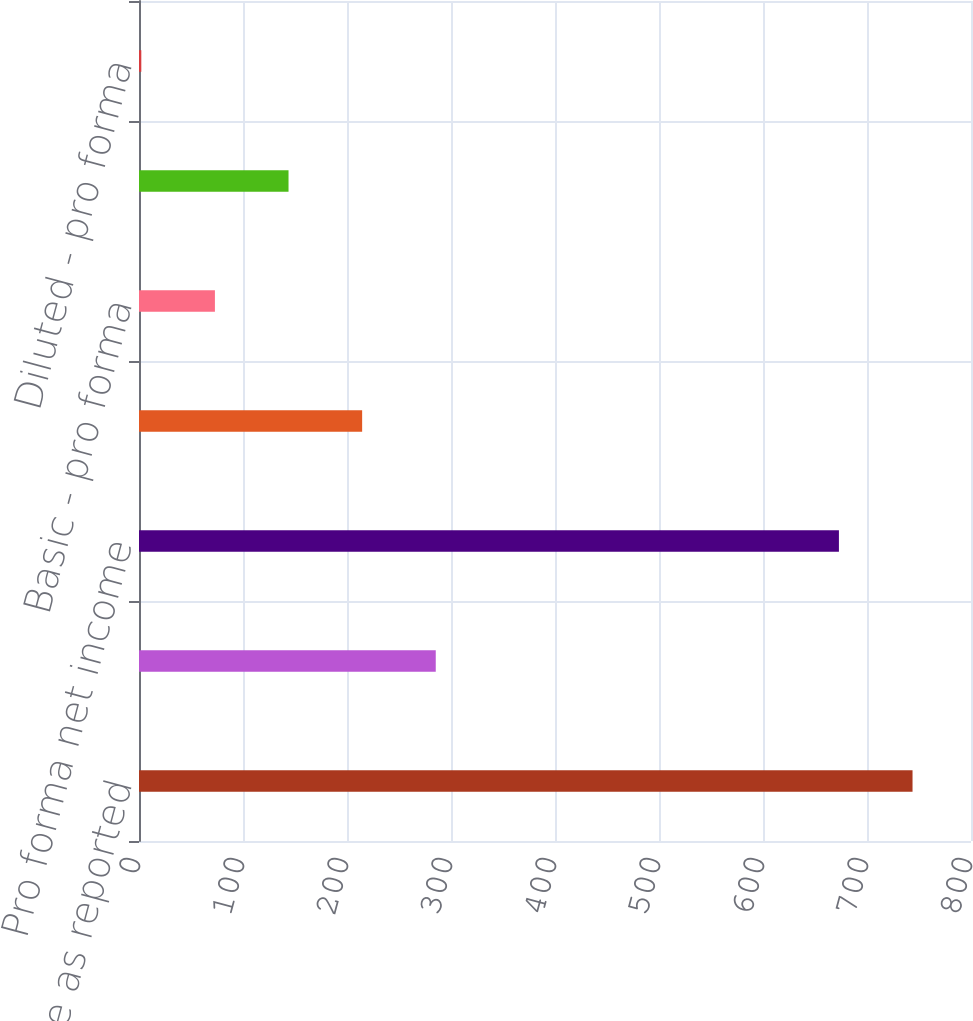<chart> <loc_0><loc_0><loc_500><loc_500><bar_chart><fcel>Net income as reported<fcel>Deduct Total stock-based<fcel>Pro forma net income<fcel>Basic - as reported<fcel>Basic - pro forma<fcel>Diluted - as reported<fcel>Diluted - pro forma<nl><fcel>743.78<fcel>285.34<fcel>673<fcel>214.56<fcel>73<fcel>143.78<fcel>2.22<nl></chart> 